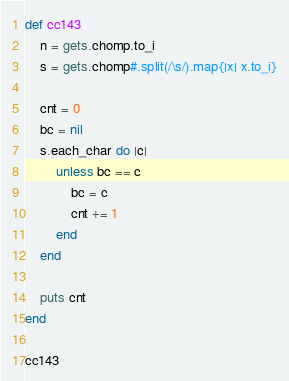Convert code to text. <code><loc_0><loc_0><loc_500><loc_500><_Ruby_>def cc143
    n = gets.chomp.to_i
    s = gets.chomp#.split(/\s/).map{|x| x.to_i}

    cnt = 0
    bc = nil
    s.each_char do |c|
        unless bc == c
            bc = c
            cnt += 1
        end
    end

    puts cnt
end

cc143</code> 